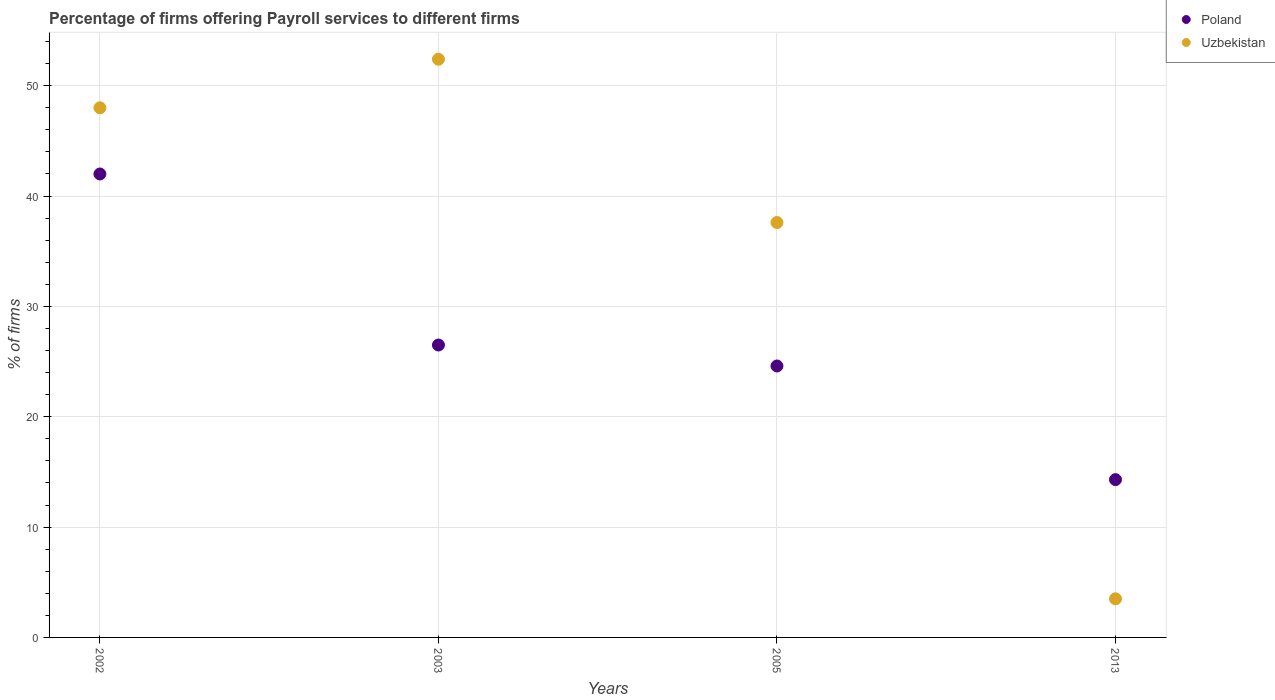How many different coloured dotlines are there?
Provide a succinct answer. 2. Is the number of dotlines equal to the number of legend labels?
Offer a terse response. Yes. What is the percentage of firms offering payroll services in Uzbekistan in 2013?
Keep it short and to the point. 3.5. Across all years, what is the maximum percentage of firms offering payroll services in Uzbekistan?
Make the answer very short. 52.4. Across all years, what is the minimum percentage of firms offering payroll services in Uzbekistan?
Provide a succinct answer. 3.5. What is the total percentage of firms offering payroll services in Poland in the graph?
Make the answer very short. 107.4. What is the average percentage of firms offering payroll services in Poland per year?
Ensure brevity in your answer.  26.85. In how many years, is the percentage of firms offering payroll services in Uzbekistan greater than 26 %?
Offer a terse response. 3. What is the ratio of the percentage of firms offering payroll services in Uzbekistan in 2003 to that in 2005?
Offer a very short reply. 1.39. Is the difference between the percentage of firms offering payroll services in Poland in 2003 and 2013 greater than the difference between the percentage of firms offering payroll services in Uzbekistan in 2003 and 2013?
Ensure brevity in your answer.  No. What is the difference between the highest and the second highest percentage of firms offering payroll services in Uzbekistan?
Provide a succinct answer. 4.4. What is the difference between the highest and the lowest percentage of firms offering payroll services in Poland?
Your answer should be very brief. 27.7. Is the sum of the percentage of firms offering payroll services in Uzbekistan in 2002 and 2005 greater than the maximum percentage of firms offering payroll services in Poland across all years?
Your answer should be compact. Yes. Does the percentage of firms offering payroll services in Poland monotonically increase over the years?
Offer a terse response. No. How many dotlines are there?
Your response must be concise. 2. Does the graph contain any zero values?
Ensure brevity in your answer.  No. What is the title of the graph?
Provide a short and direct response. Percentage of firms offering Payroll services to different firms. What is the label or title of the X-axis?
Ensure brevity in your answer.  Years. What is the label or title of the Y-axis?
Keep it short and to the point. % of firms. What is the % of firms of Poland in 2003?
Your answer should be compact. 26.5. What is the % of firms of Uzbekistan in 2003?
Provide a short and direct response. 52.4. What is the % of firms of Poland in 2005?
Provide a succinct answer. 24.6. What is the % of firms of Uzbekistan in 2005?
Provide a succinct answer. 37.6. Across all years, what is the maximum % of firms of Uzbekistan?
Provide a short and direct response. 52.4. What is the total % of firms of Poland in the graph?
Make the answer very short. 107.4. What is the total % of firms in Uzbekistan in the graph?
Give a very brief answer. 141.5. What is the difference between the % of firms in Poland in 2002 and that in 2003?
Your response must be concise. 15.5. What is the difference between the % of firms in Uzbekistan in 2002 and that in 2003?
Your answer should be compact. -4.4. What is the difference between the % of firms in Poland in 2002 and that in 2013?
Your answer should be very brief. 27.7. What is the difference between the % of firms in Uzbekistan in 2002 and that in 2013?
Give a very brief answer. 44.5. What is the difference between the % of firms of Uzbekistan in 2003 and that in 2005?
Ensure brevity in your answer.  14.8. What is the difference between the % of firms in Uzbekistan in 2003 and that in 2013?
Provide a succinct answer. 48.9. What is the difference between the % of firms in Poland in 2005 and that in 2013?
Provide a succinct answer. 10.3. What is the difference between the % of firms in Uzbekistan in 2005 and that in 2013?
Your answer should be very brief. 34.1. What is the difference between the % of firms in Poland in 2002 and the % of firms in Uzbekistan in 2003?
Offer a terse response. -10.4. What is the difference between the % of firms of Poland in 2002 and the % of firms of Uzbekistan in 2005?
Keep it short and to the point. 4.4. What is the difference between the % of firms in Poland in 2002 and the % of firms in Uzbekistan in 2013?
Give a very brief answer. 38.5. What is the difference between the % of firms in Poland in 2003 and the % of firms in Uzbekistan in 2005?
Give a very brief answer. -11.1. What is the difference between the % of firms in Poland in 2003 and the % of firms in Uzbekistan in 2013?
Ensure brevity in your answer.  23. What is the difference between the % of firms of Poland in 2005 and the % of firms of Uzbekistan in 2013?
Make the answer very short. 21.1. What is the average % of firms in Poland per year?
Offer a terse response. 26.85. What is the average % of firms in Uzbekistan per year?
Provide a succinct answer. 35.38. In the year 2003, what is the difference between the % of firms in Poland and % of firms in Uzbekistan?
Ensure brevity in your answer.  -25.9. In the year 2005, what is the difference between the % of firms of Poland and % of firms of Uzbekistan?
Make the answer very short. -13. What is the ratio of the % of firms in Poland in 2002 to that in 2003?
Your answer should be very brief. 1.58. What is the ratio of the % of firms in Uzbekistan in 2002 to that in 2003?
Offer a very short reply. 0.92. What is the ratio of the % of firms in Poland in 2002 to that in 2005?
Your answer should be compact. 1.71. What is the ratio of the % of firms of Uzbekistan in 2002 to that in 2005?
Keep it short and to the point. 1.28. What is the ratio of the % of firms in Poland in 2002 to that in 2013?
Ensure brevity in your answer.  2.94. What is the ratio of the % of firms in Uzbekistan in 2002 to that in 2013?
Provide a succinct answer. 13.71. What is the ratio of the % of firms of Poland in 2003 to that in 2005?
Your response must be concise. 1.08. What is the ratio of the % of firms in Uzbekistan in 2003 to that in 2005?
Make the answer very short. 1.39. What is the ratio of the % of firms of Poland in 2003 to that in 2013?
Offer a very short reply. 1.85. What is the ratio of the % of firms in Uzbekistan in 2003 to that in 2013?
Offer a terse response. 14.97. What is the ratio of the % of firms of Poland in 2005 to that in 2013?
Your response must be concise. 1.72. What is the ratio of the % of firms of Uzbekistan in 2005 to that in 2013?
Offer a very short reply. 10.74. What is the difference between the highest and the second highest % of firms in Poland?
Make the answer very short. 15.5. What is the difference between the highest and the lowest % of firms of Poland?
Your answer should be very brief. 27.7. What is the difference between the highest and the lowest % of firms of Uzbekistan?
Keep it short and to the point. 48.9. 